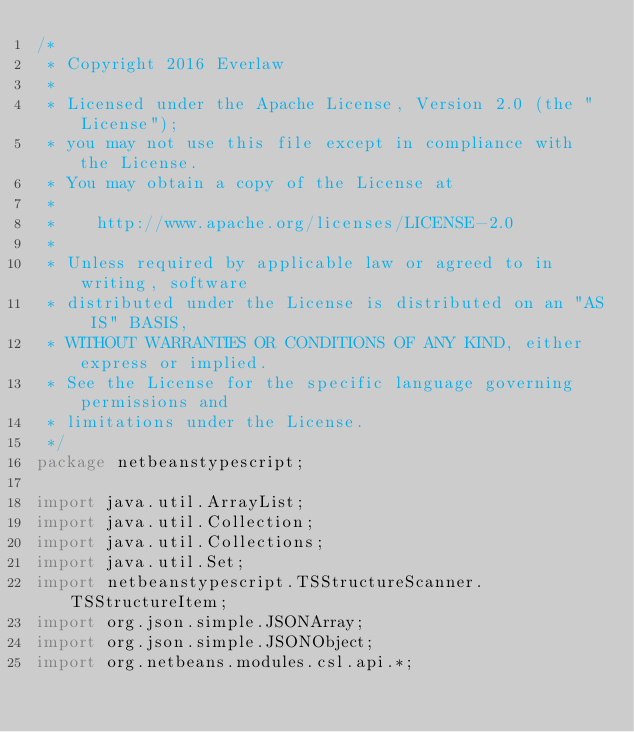<code> <loc_0><loc_0><loc_500><loc_500><_Java_>/*
 * Copyright 2016 Everlaw
 *
 * Licensed under the Apache License, Version 2.0 (the "License");
 * you may not use this file except in compliance with the License.
 * You may obtain a copy of the License at
 *
 *    http://www.apache.org/licenses/LICENSE-2.0
 *
 * Unless required by applicable law or agreed to in writing, software
 * distributed under the License is distributed on an "AS IS" BASIS,
 * WITHOUT WARRANTIES OR CONDITIONS OF ANY KIND, either express or implied.
 * See the License for the specific language governing permissions and
 * limitations under the License.
 */
package netbeanstypescript;

import java.util.ArrayList;
import java.util.Collection;
import java.util.Collections;
import java.util.Set;
import netbeanstypescript.TSStructureScanner.TSStructureItem;
import org.json.simple.JSONArray;
import org.json.simple.JSONObject;
import org.netbeans.modules.csl.api.*;</code> 